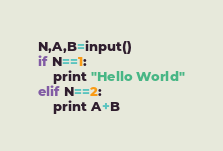Convert code to text. <code><loc_0><loc_0><loc_500><loc_500><_Python_>N,A,B=input()
if N==1:
    print "Hello World"
elif N==2:
    print A+B</code> 